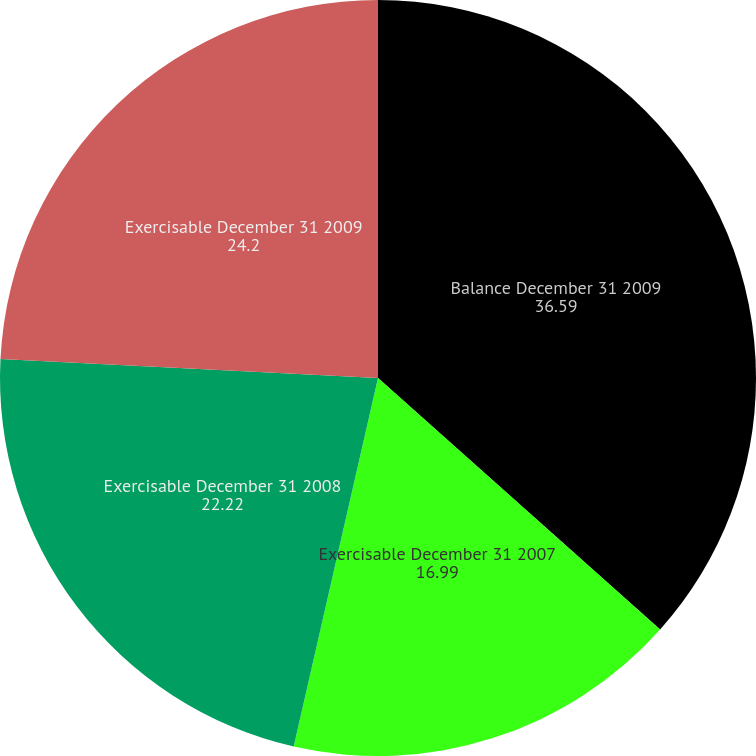Convert chart to OTSL. <chart><loc_0><loc_0><loc_500><loc_500><pie_chart><fcel>Balance December 31 2009<fcel>Exercisable December 31 2007<fcel>Exercisable December 31 2008<fcel>Exercisable December 31 2009<nl><fcel>36.59%<fcel>16.99%<fcel>22.22%<fcel>24.2%<nl></chart> 